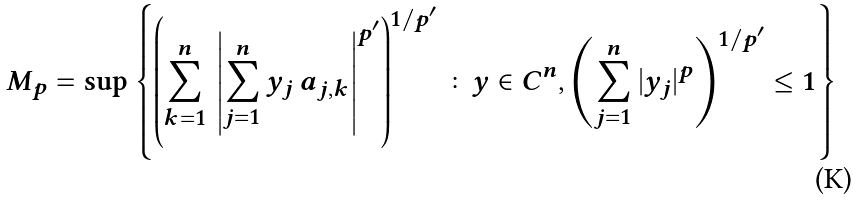<formula> <loc_0><loc_0><loc_500><loc_500>M _ { p } = \sup \left \{ \left ( \sum _ { k = 1 } ^ { n } \, \left | \sum _ { j = 1 } ^ { n } y _ { j } \, a _ { j , k } \right | ^ { p ^ { \prime } } \right ) ^ { 1 / p ^ { \prime } } \colon y \in { C } ^ { n } , \left ( \sum _ { j = 1 } ^ { n } | y _ { j } | ^ { p } \right ) ^ { 1 / p ^ { \prime } } \leq 1 \right \}</formula> 